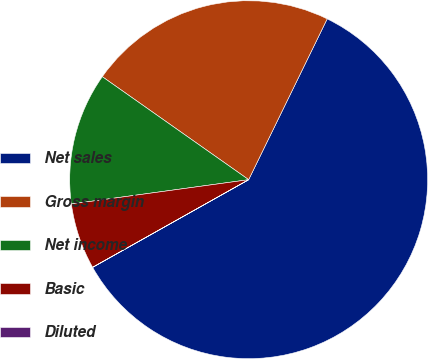<chart> <loc_0><loc_0><loc_500><loc_500><pie_chart><fcel>Net sales<fcel>Gross margin<fcel>Net income<fcel>Basic<fcel>Diluted<nl><fcel>59.62%<fcel>22.47%<fcel>11.93%<fcel>5.97%<fcel>0.01%<nl></chart> 